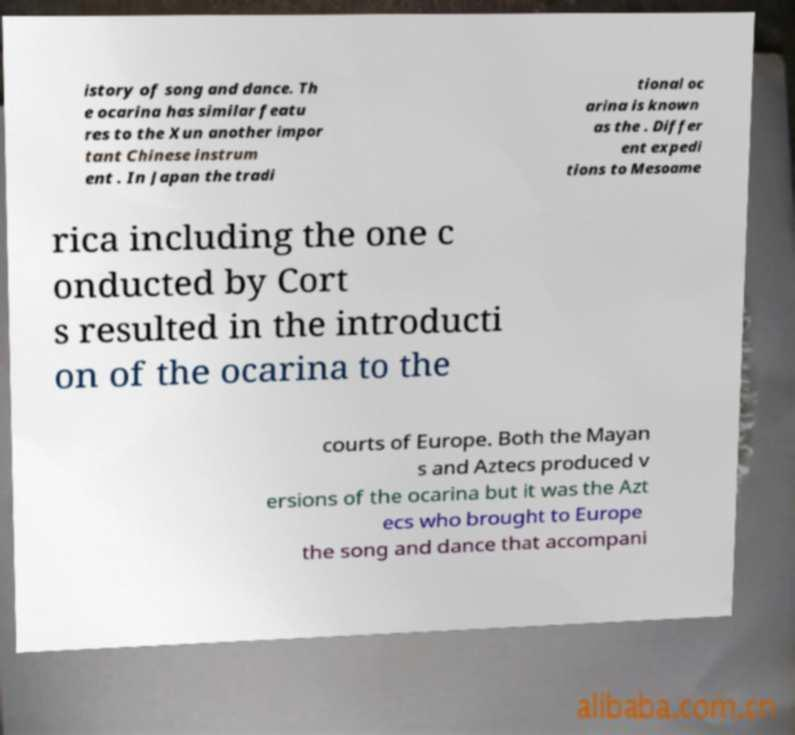Please identify and transcribe the text found in this image. istory of song and dance. Th e ocarina has similar featu res to the Xun another impor tant Chinese instrum ent . In Japan the tradi tional oc arina is known as the . Differ ent expedi tions to Mesoame rica including the one c onducted by Cort s resulted in the introducti on of the ocarina to the courts of Europe. Both the Mayan s and Aztecs produced v ersions of the ocarina but it was the Azt ecs who brought to Europe the song and dance that accompani 